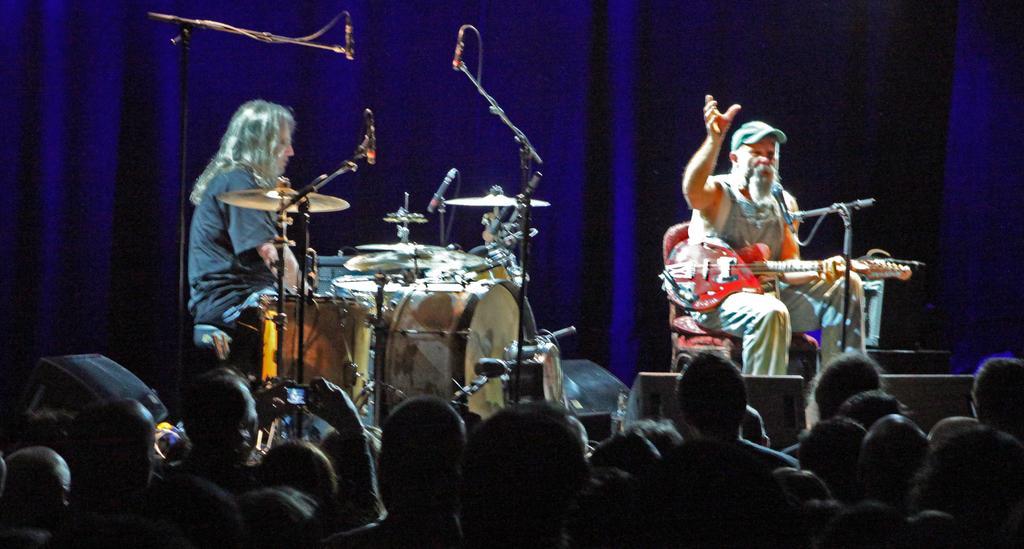Can you describe this image briefly? This picture shows two men playing musical instruments a man holding a guitar in his hand and speaking with the help of a microphone in front him and we see a man seated in front of drums 